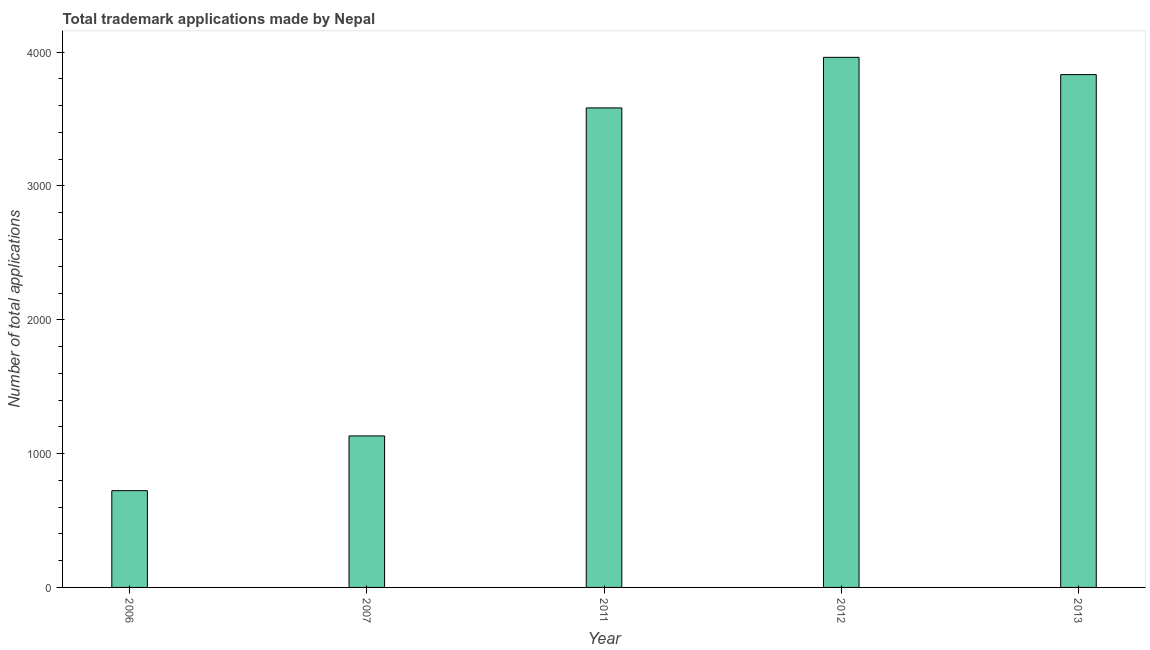What is the title of the graph?
Offer a terse response. Total trademark applications made by Nepal. What is the label or title of the X-axis?
Keep it short and to the point. Year. What is the label or title of the Y-axis?
Offer a very short reply. Number of total applications. What is the number of trademark applications in 2006?
Offer a terse response. 723. Across all years, what is the maximum number of trademark applications?
Offer a terse response. 3961. Across all years, what is the minimum number of trademark applications?
Your response must be concise. 723. What is the sum of the number of trademark applications?
Offer a terse response. 1.32e+04. What is the difference between the number of trademark applications in 2007 and 2011?
Keep it short and to the point. -2451. What is the average number of trademark applications per year?
Provide a short and direct response. 2646. What is the median number of trademark applications?
Provide a short and direct response. 3583. In how many years, is the number of trademark applications greater than 800 ?
Keep it short and to the point. 4. What is the ratio of the number of trademark applications in 2006 to that in 2012?
Your answer should be very brief. 0.18. Is the difference between the number of trademark applications in 2007 and 2012 greater than the difference between any two years?
Your answer should be compact. No. What is the difference between the highest and the second highest number of trademark applications?
Offer a very short reply. 129. Is the sum of the number of trademark applications in 2011 and 2012 greater than the maximum number of trademark applications across all years?
Your answer should be compact. Yes. What is the difference between the highest and the lowest number of trademark applications?
Provide a succinct answer. 3238. In how many years, is the number of trademark applications greater than the average number of trademark applications taken over all years?
Your response must be concise. 3. Are all the bars in the graph horizontal?
Your answer should be compact. No. How many years are there in the graph?
Provide a succinct answer. 5. What is the difference between two consecutive major ticks on the Y-axis?
Ensure brevity in your answer.  1000. Are the values on the major ticks of Y-axis written in scientific E-notation?
Provide a short and direct response. No. What is the Number of total applications of 2006?
Provide a short and direct response. 723. What is the Number of total applications of 2007?
Ensure brevity in your answer.  1132. What is the Number of total applications of 2011?
Your answer should be very brief. 3583. What is the Number of total applications of 2012?
Give a very brief answer. 3961. What is the Number of total applications in 2013?
Your answer should be compact. 3832. What is the difference between the Number of total applications in 2006 and 2007?
Your response must be concise. -409. What is the difference between the Number of total applications in 2006 and 2011?
Give a very brief answer. -2860. What is the difference between the Number of total applications in 2006 and 2012?
Offer a very short reply. -3238. What is the difference between the Number of total applications in 2006 and 2013?
Make the answer very short. -3109. What is the difference between the Number of total applications in 2007 and 2011?
Your answer should be compact. -2451. What is the difference between the Number of total applications in 2007 and 2012?
Give a very brief answer. -2829. What is the difference between the Number of total applications in 2007 and 2013?
Offer a terse response. -2700. What is the difference between the Number of total applications in 2011 and 2012?
Give a very brief answer. -378. What is the difference between the Number of total applications in 2011 and 2013?
Ensure brevity in your answer.  -249. What is the difference between the Number of total applications in 2012 and 2013?
Your answer should be compact. 129. What is the ratio of the Number of total applications in 2006 to that in 2007?
Give a very brief answer. 0.64. What is the ratio of the Number of total applications in 2006 to that in 2011?
Your response must be concise. 0.2. What is the ratio of the Number of total applications in 2006 to that in 2012?
Your answer should be compact. 0.18. What is the ratio of the Number of total applications in 2006 to that in 2013?
Offer a terse response. 0.19. What is the ratio of the Number of total applications in 2007 to that in 2011?
Make the answer very short. 0.32. What is the ratio of the Number of total applications in 2007 to that in 2012?
Your answer should be compact. 0.29. What is the ratio of the Number of total applications in 2007 to that in 2013?
Your answer should be compact. 0.29. What is the ratio of the Number of total applications in 2011 to that in 2012?
Provide a succinct answer. 0.91. What is the ratio of the Number of total applications in 2011 to that in 2013?
Offer a terse response. 0.94. What is the ratio of the Number of total applications in 2012 to that in 2013?
Your answer should be very brief. 1.03. 